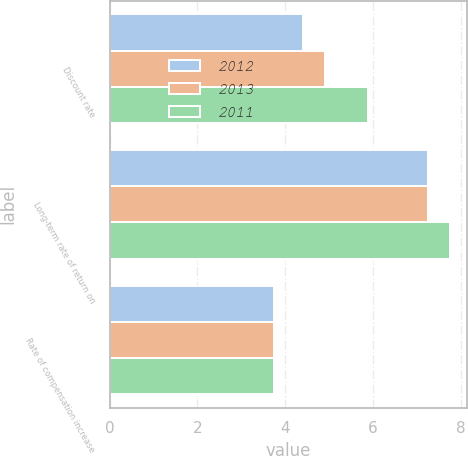<chart> <loc_0><loc_0><loc_500><loc_500><stacked_bar_chart><ecel><fcel>Discount rate<fcel>Long-term rate of return on<fcel>Rate of compensation increase<nl><fcel>2012<fcel>4.4<fcel>7.25<fcel>3.75<nl><fcel>2013<fcel>4.9<fcel>7.25<fcel>3.75<nl><fcel>2011<fcel>5.9<fcel>7.75<fcel>3.75<nl></chart> 